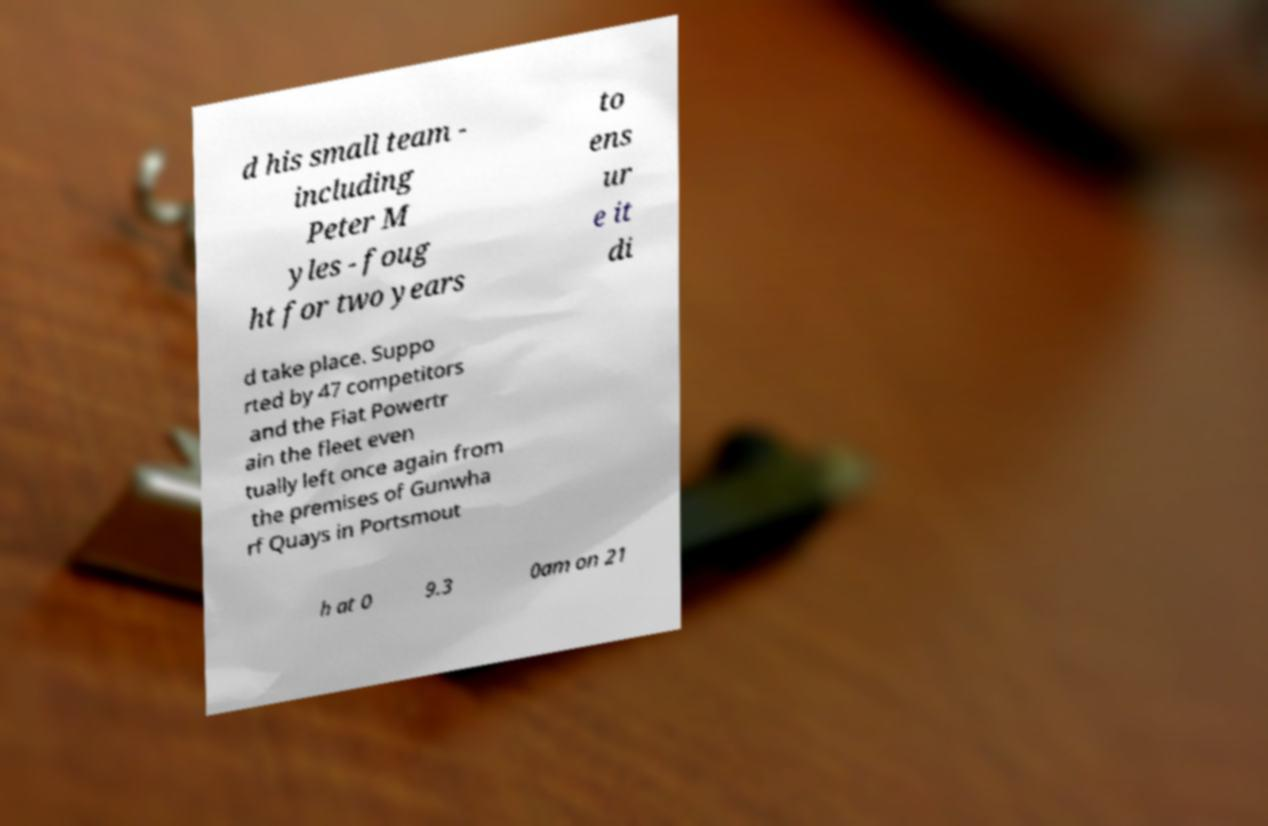Could you assist in decoding the text presented in this image and type it out clearly? d his small team - including Peter M yles - foug ht for two years to ens ur e it di d take place. Suppo rted by 47 competitors and the Fiat Powertr ain the fleet even tually left once again from the premises of Gunwha rf Quays in Portsmout h at 0 9.3 0am on 21 